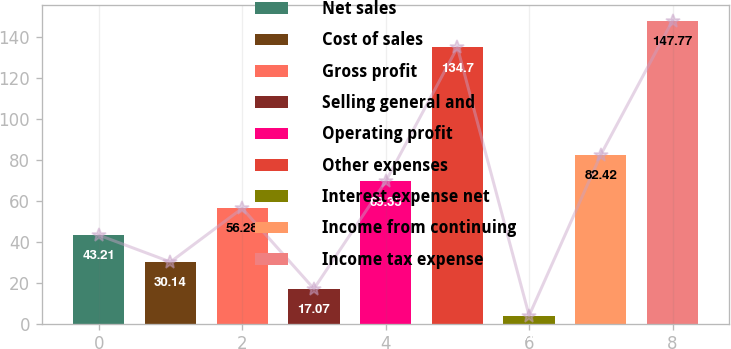Convert chart. <chart><loc_0><loc_0><loc_500><loc_500><bar_chart><fcel>Net sales<fcel>Cost of sales<fcel>Gross profit<fcel>Selling general and<fcel>Operating profit<fcel>Other expenses<fcel>Interest expense net<fcel>Income from continuing<fcel>Income tax expense<nl><fcel>43.21<fcel>30.14<fcel>56.28<fcel>17.07<fcel>69.35<fcel>134.7<fcel>4<fcel>82.42<fcel>147.77<nl></chart> 